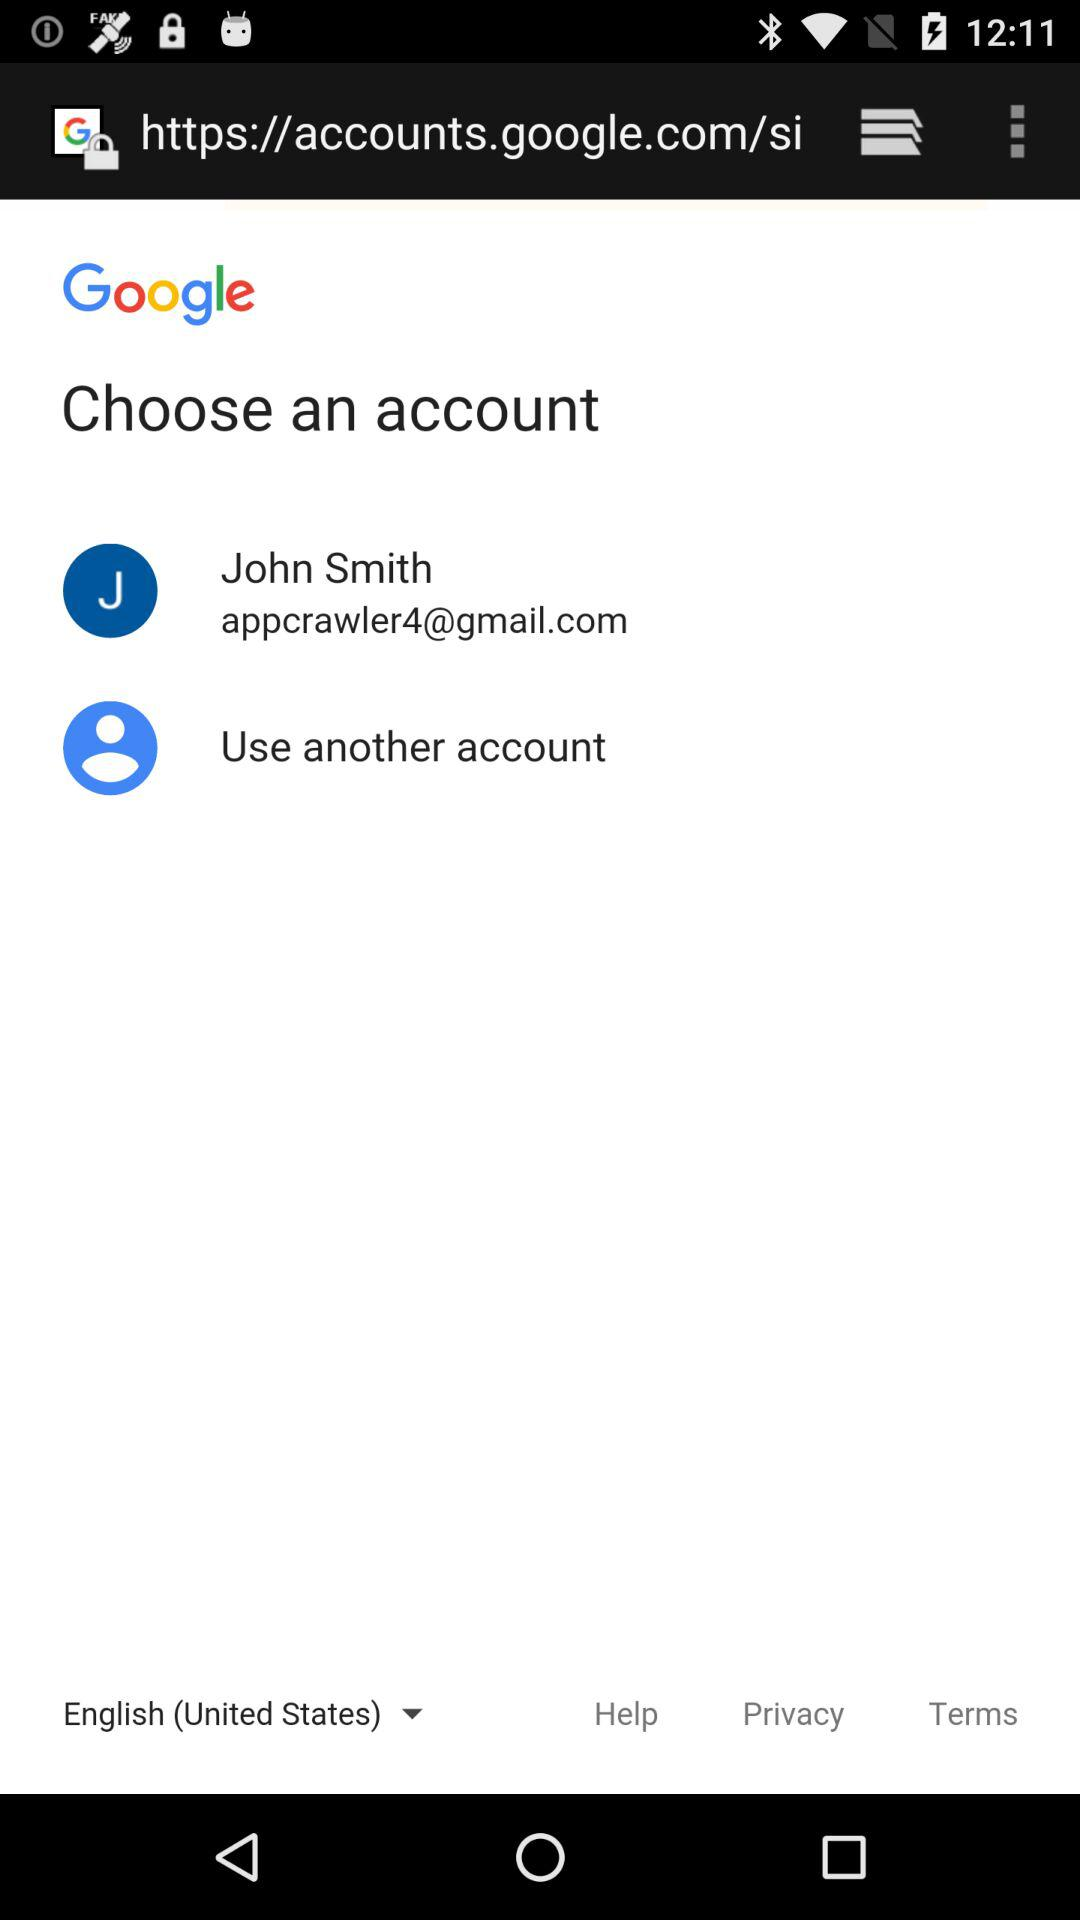What is the selected language? The selected language is "English (United States)". 